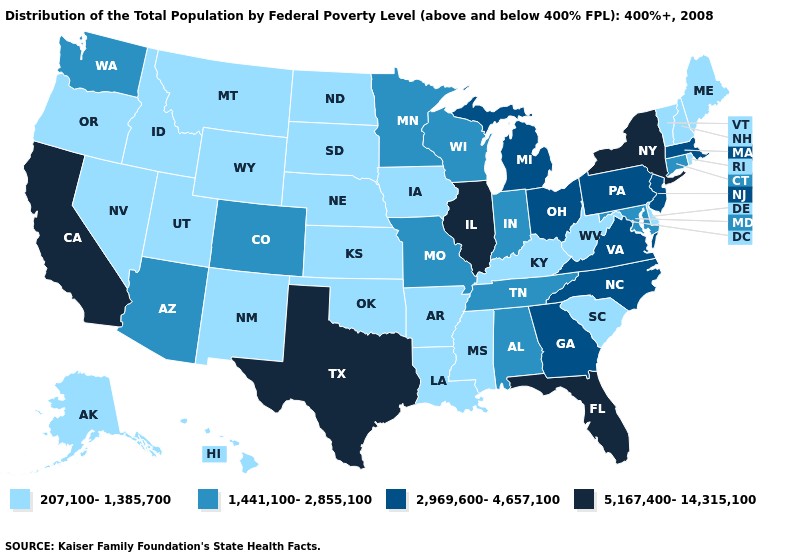Name the states that have a value in the range 5,167,400-14,315,100?
Write a very short answer. California, Florida, Illinois, New York, Texas. What is the value of Oklahoma?
Answer briefly. 207,100-1,385,700. Which states have the lowest value in the USA?
Keep it brief. Alaska, Arkansas, Delaware, Hawaii, Idaho, Iowa, Kansas, Kentucky, Louisiana, Maine, Mississippi, Montana, Nebraska, Nevada, New Hampshire, New Mexico, North Dakota, Oklahoma, Oregon, Rhode Island, South Carolina, South Dakota, Utah, Vermont, West Virginia, Wyoming. What is the highest value in the USA?
Give a very brief answer. 5,167,400-14,315,100. What is the lowest value in states that border Illinois?
Be succinct. 207,100-1,385,700. Which states have the highest value in the USA?
Be succinct. California, Florida, Illinois, New York, Texas. What is the lowest value in the South?
Answer briefly. 207,100-1,385,700. Does the map have missing data?
Write a very short answer. No. Which states have the highest value in the USA?
Quick response, please. California, Florida, Illinois, New York, Texas. Name the states that have a value in the range 5,167,400-14,315,100?
Short answer required. California, Florida, Illinois, New York, Texas. Name the states that have a value in the range 2,969,600-4,657,100?
Be succinct. Georgia, Massachusetts, Michigan, New Jersey, North Carolina, Ohio, Pennsylvania, Virginia. Name the states that have a value in the range 5,167,400-14,315,100?
Give a very brief answer. California, Florida, Illinois, New York, Texas. Among the states that border South Dakota , which have the highest value?
Write a very short answer. Minnesota. Does Nevada have a lower value than Mississippi?
Answer briefly. No. Among the states that border Missouri , does Illinois have the lowest value?
Keep it brief. No. 